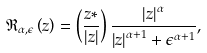<formula> <loc_0><loc_0><loc_500><loc_500>\mathfrak { R _ { \alpha , \epsilon } } \left ( z \right ) = \left ( \frac { z * } { \left | z \right | } \right ) \frac { \left | z \right | ^ { \alpha } } { \left | z \right | ^ { \alpha + 1 } + \epsilon ^ { \alpha + 1 } } ,</formula> 